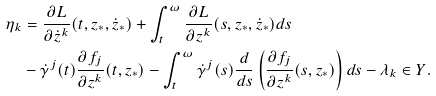<formula> <loc_0><loc_0><loc_500><loc_500>\eta _ { k } & = \frac { \partial L } { \partial \dot { z } ^ { k } } ( t , z _ { * } , \dot { z } _ { * } ) + \int _ { t } ^ { \omega } \frac { \partial L } { \partial z ^ { k } } ( s , z _ { * } , \dot { z } _ { * } ) d s \\ & - \dot { \gamma } ^ { j } ( t ) \frac { \partial f _ { j } } { \partial z ^ { k } } ( t , z _ { * } ) - \int _ { t } ^ { \omega } \dot { \gamma } ^ { j } ( s ) \frac { d } { d s } \left ( \frac { \partial f _ { j } } { \partial z ^ { k } } ( s , z _ { * } ) \right ) d s - \lambda _ { k } \in Y .</formula> 